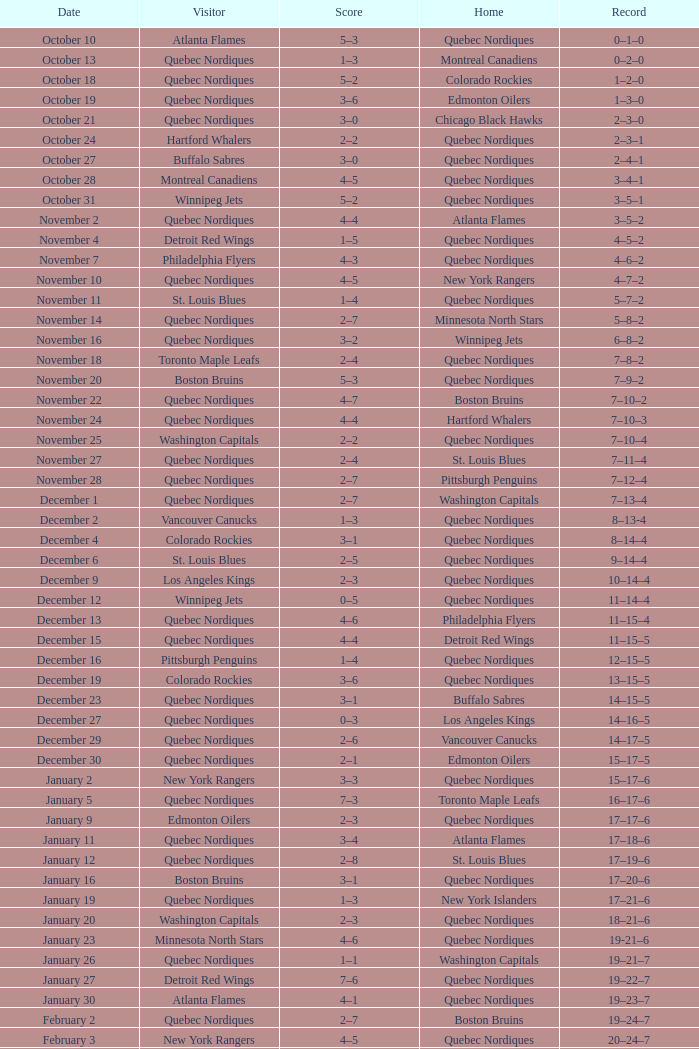When is a score of 2-7 linked with a record of 5-8-2? November 14. 